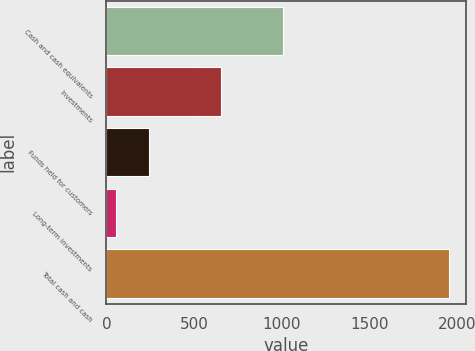<chart> <loc_0><loc_0><loc_500><loc_500><bar_chart><fcel>Cash and cash equivalents<fcel>Investments<fcel>Funds held for customers<fcel>Long-term investments<fcel>Total cash and cash<nl><fcel>1009<fcel>653<fcel>243.7<fcel>54<fcel>1951<nl></chart> 